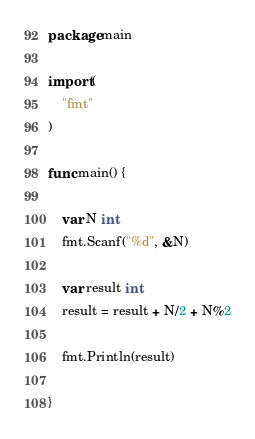<code> <loc_0><loc_0><loc_500><loc_500><_Go_>package main

import (
	"fmt"
)

func main() {

	var N int
	fmt.Scanf("%d", &N)

	var result int
	result = result + N/2 + N%2

	fmt.Println(result)

}
</code> 